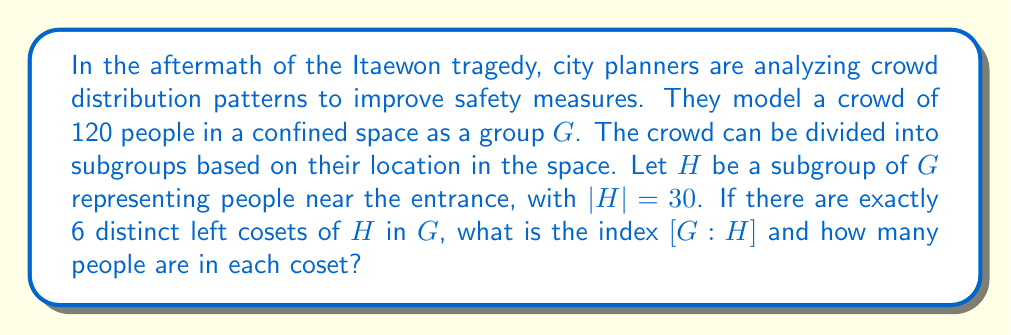Show me your answer to this math problem. To solve this problem, we'll use concepts from group theory:

1) First, recall the definition of index. For a group $G$ and a subgroup $H$, the index $[G:H]$ is the number of distinct left cosets of $H$ in $G$.

2) We're given that there are exactly 6 distinct left cosets of $H$ in $G$. Therefore:

   $[G:H] = 6$

3) Next, we can use Lagrange's theorem, which states that for a finite group $G$ and a subgroup $H$:

   $|G| = |H| \cdot [G:H]$

4) We know that $|G| = 120$ (total people in the crowd) and $|H| = 30$ (people near the entrance). Let's verify:

   $120 = 30 \cdot 6$

   This checks out, confirming our understanding of the situation.

5) To find how many people are in each coset, we can use the fact that all cosets of a subgroup have the same number of elements as the subgroup itself. Therefore, each coset will have $|H| = 30$ people.

This analysis shows how group theory can be applied to understand crowd distribution, which is crucial for improving safety measures in confined spaces.
Answer: The index $[G:H]$ is 6, and each coset contains 30 people. 